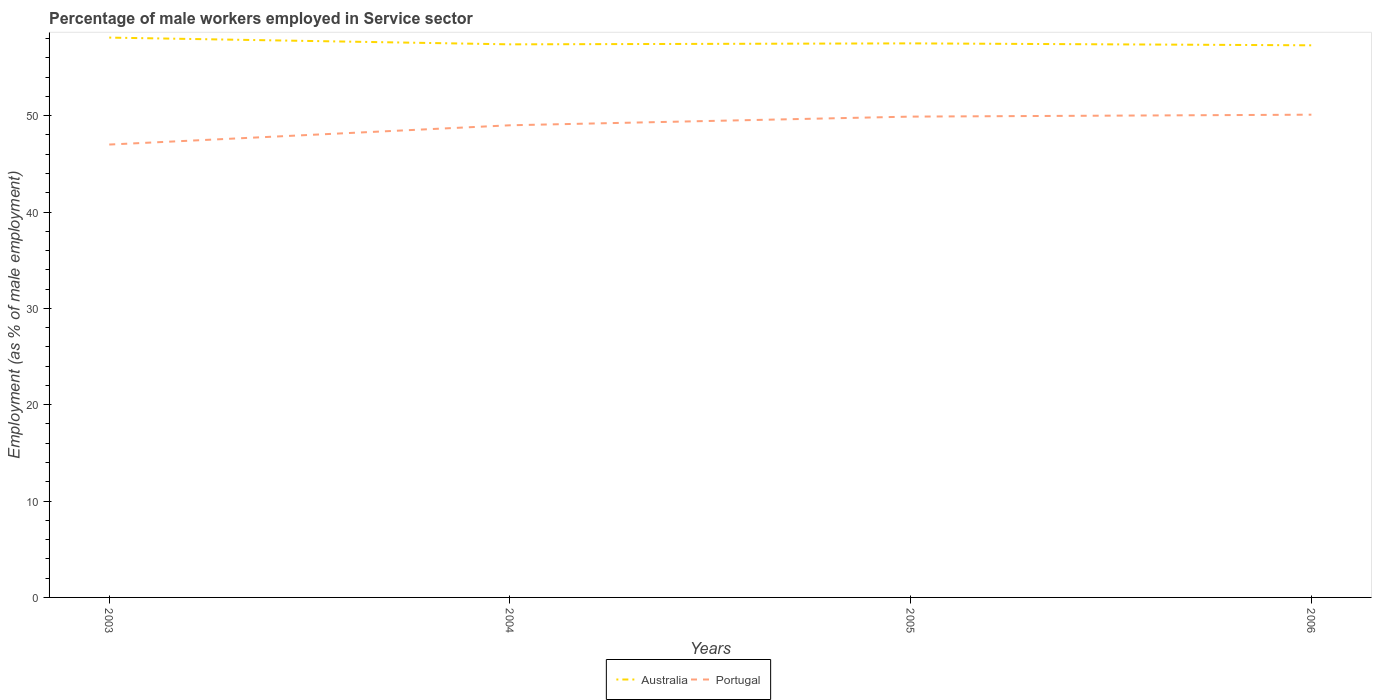How many different coloured lines are there?
Make the answer very short. 2. Is the number of lines equal to the number of legend labels?
Give a very brief answer. Yes. Across all years, what is the maximum percentage of male workers employed in Service sector in Portugal?
Offer a terse response. 47. What is the total percentage of male workers employed in Service sector in Portugal in the graph?
Give a very brief answer. -1.1. What is the difference between the highest and the second highest percentage of male workers employed in Service sector in Australia?
Provide a succinct answer. 0.8. What is the difference between the highest and the lowest percentage of male workers employed in Service sector in Portugal?
Your answer should be very brief. 2. Is the percentage of male workers employed in Service sector in Portugal strictly greater than the percentage of male workers employed in Service sector in Australia over the years?
Offer a terse response. Yes. How many lines are there?
Your response must be concise. 2. How many years are there in the graph?
Make the answer very short. 4. What is the difference between two consecutive major ticks on the Y-axis?
Your response must be concise. 10. Does the graph contain any zero values?
Provide a short and direct response. No. Does the graph contain grids?
Ensure brevity in your answer.  No. Where does the legend appear in the graph?
Give a very brief answer. Bottom center. How many legend labels are there?
Offer a terse response. 2. What is the title of the graph?
Provide a succinct answer. Percentage of male workers employed in Service sector. What is the label or title of the Y-axis?
Your answer should be compact. Employment (as % of male employment). What is the Employment (as % of male employment) of Australia in 2003?
Make the answer very short. 58.1. What is the Employment (as % of male employment) in Australia in 2004?
Provide a succinct answer. 57.4. What is the Employment (as % of male employment) in Australia in 2005?
Provide a succinct answer. 57.5. What is the Employment (as % of male employment) in Portugal in 2005?
Ensure brevity in your answer.  49.9. What is the Employment (as % of male employment) in Australia in 2006?
Provide a succinct answer. 57.3. What is the Employment (as % of male employment) of Portugal in 2006?
Your answer should be very brief. 50.1. Across all years, what is the maximum Employment (as % of male employment) in Australia?
Your response must be concise. 58.1. Across all years, what is the maximum Employment (as % of male employment) in Portugal?
Your answer should be very brief. 50.1. Across all years, what is the minimum Employment (as % of male employment) of Australia?
Your answer should be compact. 57.3. What is the total Employment (as % of male employment) in Australia in the graph?
Offer a terse response. 230.3. What is the total Employment (as % of male employment) of Portugal in the graph?
Your answer should be compact. 196. What is the difference between the Employment (as % of male employment) in Australia in 2003 and that in 2004?
Your answer should be very brief. 0.7. What is the difference between the Employment (as % of male employment) of Australia in 2003 and that in 2005?
Provide a succinct answer. 0.6. What is the difference between the Employment (as % of male employment) of Portugal in 2003 and that in 2006?
Offer a very short reply. -3.1. What is the difference between the Employment (as % of male employment) of Portugal in 2004 and that in 2006?
Give a very brief answer. -1.1. What is the difference between the Employment (as % of male employment) of Portugal in 2005 and that in 2006?
Your answer should be compact. -0.2. What is the difference between the Employment (as % of male employment) in Australia in 2003 and the Employment (as % of male employment) in Portugal in 2004?
Offer a terse response. 9.1. What is the difference between the Employment (as % of male employment) in Australia in 2003 and the Employment (as % of male employment) in Portugal in 2005?
Give a very brief answer. 8.2. What is the average Employment (as % of male employment) of Australia per year?
Provide a short and direct response. 57.58. What is the average Employment (as % of male employment) of Portugal per year?
Provide a short and direct response. 49. In the year 2004, what is the difference between the Employment (as % of male employment) in Australia and Employment (as % of male employment) in Portugal?
Your answer should be very brief. 8.4. What is the ratio of the Employment (as % of male employment) in Australia in 2003 to that in 2004?
Your answer should be very brief. 1.01. What is the ratio of the Employment (as % of male employment) of Portugal in 2003 to that in 2004?
Provide a succinct answer. 0.96. What is the ratio of the Employment (as % of male employment) of Australia in 2003 to that in 2005?
Ensure brevity in your answer.  1.01. What is the ratio of the Employment (as % of male employment) of Portugal in 2003 to that in 2005?
Provide a short and direct response. 0.94. What is the ratio of the Employment (as % of male employment) of Portugal in 2003 to that in 2006?
Keep it short and to the point. 0.94. What is the ratio of the Employment (as % of male employment) of Australia in 2004 to that in 2005?
Provide a short and direct response. 1. What is the ratio of the Employment (as % of male employment) of Portugal in 2004 to that in 2006?
Keep it short and to the point. 0.98. 